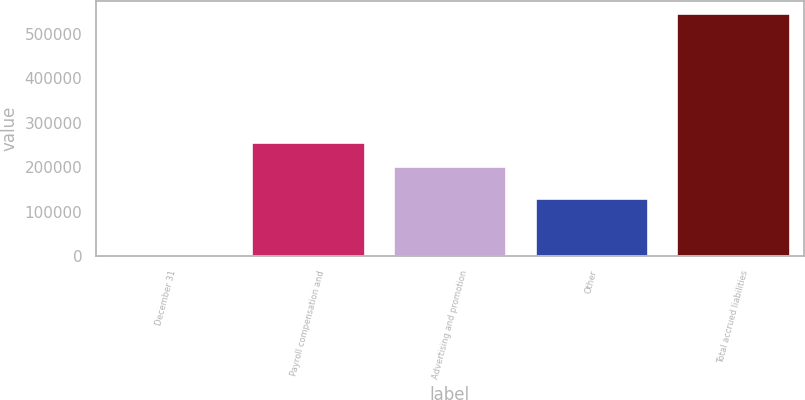Convert chart. <chart><loc_0><loc_0><loc_500><loc_500><bar_chart><fcel>December 31<fcel>Payroll compensation and<fcel>Advertising and promotion<fcel>Other<fcel>Total accrued liabilities<nl><fcel>2009<fcel>256992<fcel>202547<fcel>130200<fcel>546462<nl></chart> 